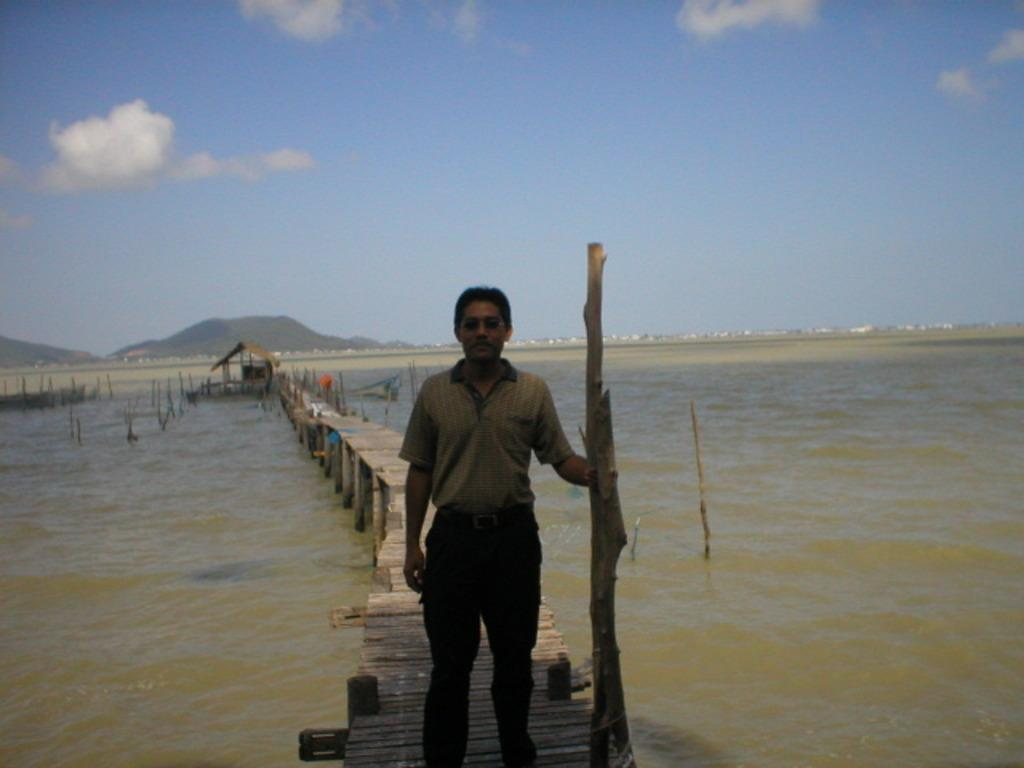What is the person in the image standing on? The person is standing on a wooden bridge. What type of material is used for the poles in the image? The poles in the image are made of wood. What is the source of heat in the image? The image contains hot water. What type of landscape can be seen in the image? Hills are visible in the image. What part of the natural environment is visible in the image? The sky is visible in the image. How many ladybugs can be seen crawling on the wooden poles in the image? There are no ladybugs present in the image; it only contains a person, wooden poles, hot water, hills, and the sky. 